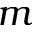Convert formula to latex. <formula><loc_0><loc_0><loc_500><loc_500>m</formula> 